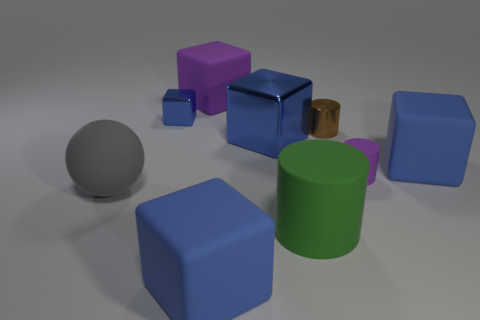Do the small block and the big metallic thing have the same color?
Make the answer very short. Yes. There is a thing that is in front of the big green rubber cylinder; what material is it?
Provide a succinct answer. Rubber. How many other objects are there of the same color as the tiny rubber object?
Make the answer very short. 1. There is a block that is the same size as the brown metallic cylinder; what is its material?
Provide a short and direct response. Metal. What number of things are rubber cubes that are behind the large ball or metal objects that are in front of the small block?
Ensure brevity in your answer.  4. Is there a large cyan metal thing of the same shape as the big purple object?
Give a very brief answer. No. What material is the cube that is the same color as the tiny rubber cylinder?
Provide a short and direct response. Rubber. What number of rubber things are either green cylinders or blue cubes?
Give a very brief answer. 3. What shape is the small purple object?
Your response must be concise. Cylinder. What number of other small blue objects are the same material as the tiny blue thing?
Provide a short and direct response. 0. 